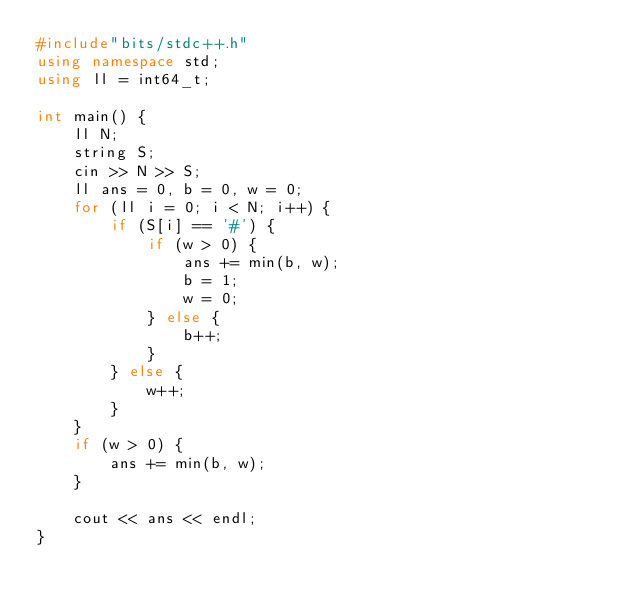<code> <loc_0><loc_0><loc_500><loc_500><_C++_>#include"bits/stdc++.h"
using namespace std;
using ll = int64_t;

int main() {
    ll N;
    string S;
    cin >> N >> S;
    ll ans = 0, b = 0, w = 0;
    for (ll i = 0; i < N; i++) {
        if (S[i] == '#') {
            if (w > 0) {
                ans += min(b, w);
                b = 1;
                w = 0;
            } else {
                b++;
            }
        } else {
            w++;
        }
    }
    if (w > 0) {
        ans += min(b, w);
    }

    cout << ans << endl;
}</code> 